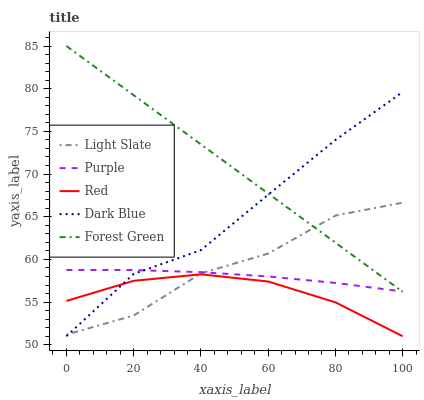Does Red have the minimum area under the curve?
Answer yes or no. Yes. Does Forest Green have the maximum area under the curve?
Answer yes or no. Yes. Does Purple have the minimum area under the curve?
Answer yes or no. No. Does Purple have the maximum area under the curve?
Answer yes or no. No. Is Forest Green the smoothest?
Answer yes or no. Yes. Is Light Slate the roughest?
Answer yes or no. Yes. Is Purple the smoothest?
Answer yes or no. No. Is Purple the roughest?
Answer yes or no. No. Does Red have the lowest value?
Answer yes or no. Yes. Does Forest Green have the lowest value?
Answer yes or no. No. Does Forest Green have the highest value?
Answer yes or no. Yes. Does Purple have the highest value?
Answer yes or no. No. Is Red less than Purple?
Answer yes or no. Yes. Is Purple greater than Red?
Answer yes or no. Yes. Does Red intersect Light Slate?
Answer yes or no. Yes. Is Red less than Light Slate?
Answer yes or no. No. Is Red greater than Light Slate?
Answer yes or no. No. Does Red intersect Purple?
Answer yes or no. No. 